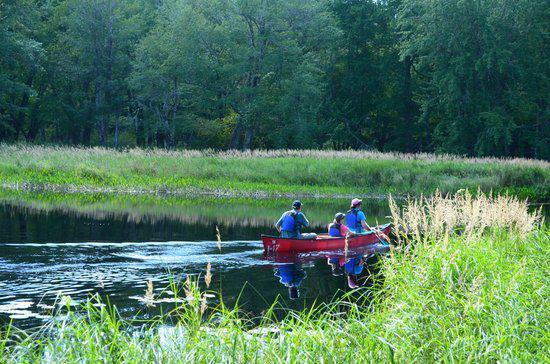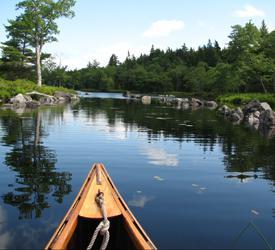The first image is the image on the left, the second image is the image on the right. For the images shown, is this caption "There is more than one boat in the image on the right." true? Answer yes or no. No. 